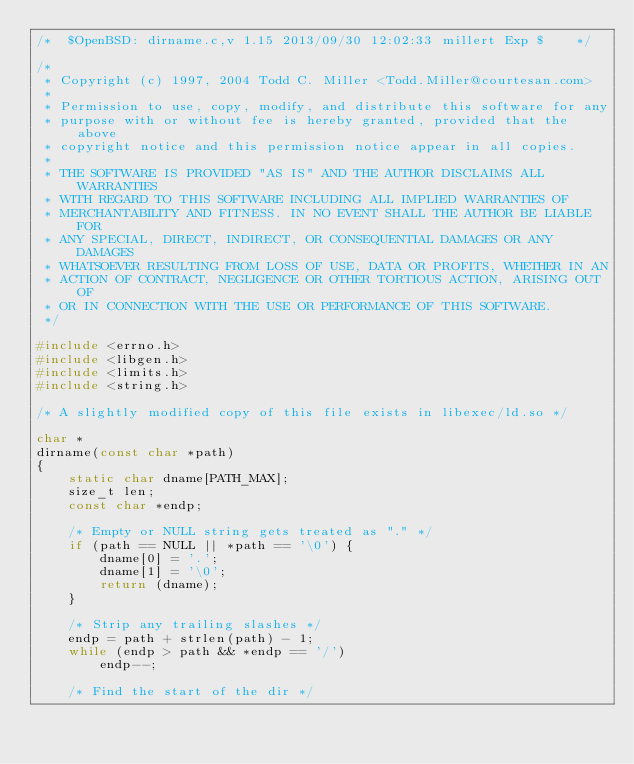Convert code to text. <code><loc_0><loc_0><loc_500><loc_500><_C_>/*	$OpenBSD: dirname.c,v 1.15 2013/09/30 12:02:33 millert Exp $	*/

/*
 * Copyright (c) 1997, 2004 Todd C. Miller <Todd.Miller@courtesan.com>
 *
 * Permission to use, copy, modify, and distribute this software for any
 * purpose with or without fee is hereby granted, provided that the above
 * copyright notice and this permission notice appear in all copies.
 *
 * THE SOFTWARE IS PROVIDED "AS IS" AND THE AUTHOR DISCLAIMS ALL WARRANTIES
 * WITH REGARD TO THIS SOFTWARE INCLUDING ALL IMPLIED WARRANTIES OF
 * MERCHANTABILITY AND FITNESS. IN NO EVENT SHALL THE AUTHOR BE LIABLE FOR
 * ANY SPECIAL, DIRECT, INDIRECT, OR CONSEQUENTIAL DAMAGES OR ANY DAMAGES
 * WHATSOEVER RESULTING FROM LOSS OF USE, DATA OR PROFITS, WHETHER IN AN
 * ACTION OF CONTRACT, NEGLIGENCE OR OTHER TORTIOUS ACTION, ARISING OUT OF
 * OR IN CONNECTION WITH THE USE OR PERFORMANCE OF THIS SOFTWARE.
 */

#include <errno.h>
#include <libgen.h>
#include <limits.h>
#include <string.h>

/* A slightly modified copy of this file exists in libexec/ld.so */

char *
dirname(const char *path)
{
	static char dname[PATH_MAX];
	size_t len;
	const char *endp;

	/* Empty or NULL string gets treated as "." */
	if (path == NULL || *path == '\0') {
		dname[0] = '.';
		dname[1] = '\0';
		return (dname);
	}

	/* Strip any trailing slashes */
	endp = path + strlen(path) - 1;
	while (endp > path && *endp == '/')
		endp--;

	/* Find the start of the dir */</code> 